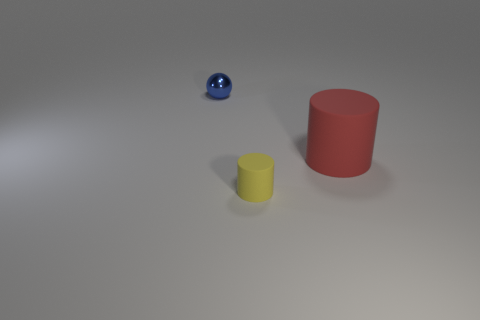Add 1 small yellow cylinders. How many objects exist? 4 Subtract all cylinders. How many objects are left? 1 Subtract all tiny cylinders. Subtract all blue things. How many objects are left? 1 Add 3 large red matte objects. How many large red matte objects are left? 4 Add 3 yellow rubber things. How many yellow rubber things exist? 4 Subtract 0 green spheres. How many objects are left? 3 